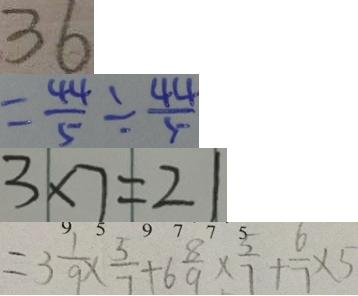<formula> <loc_0><loc_0><loc_500><loc_500>3 6 
 = \frac { 4 4 } { 5 } \div \frac { 4 4 } { 5 } 
 3 \times 7 = 2 1 
 = 3 \frac { 1 } { 9 } \times \frac { 5 } { 7 } + 6 \frac { 8 } { 9 } \times \frac { 5 } { 7 } + \frac { 6 } { 7 } \times 5</formula> 